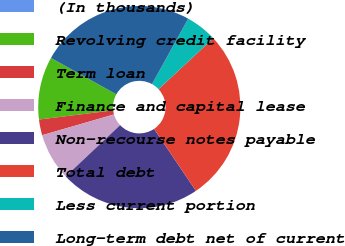Convert chart. <chart><loc_0><loc_0><loc_500><loc_500><pie_chart><fcel>(In thousands)<fcel>Revolving credit facility<fcel>Term loan<fcel>Finance and capital lease<fcel>Non-recourse notes payable<fcel>Total debt<fcel>Less current portion<fcel>Long-term debt net of current<nl><fcel>0.0%<fcel>10.05%<fcel>2.52%<fcel>7.54%<fcel>22.45%<fcel>27.47%<fcel>5.03%<fcel>24.96%<nl></chart> 